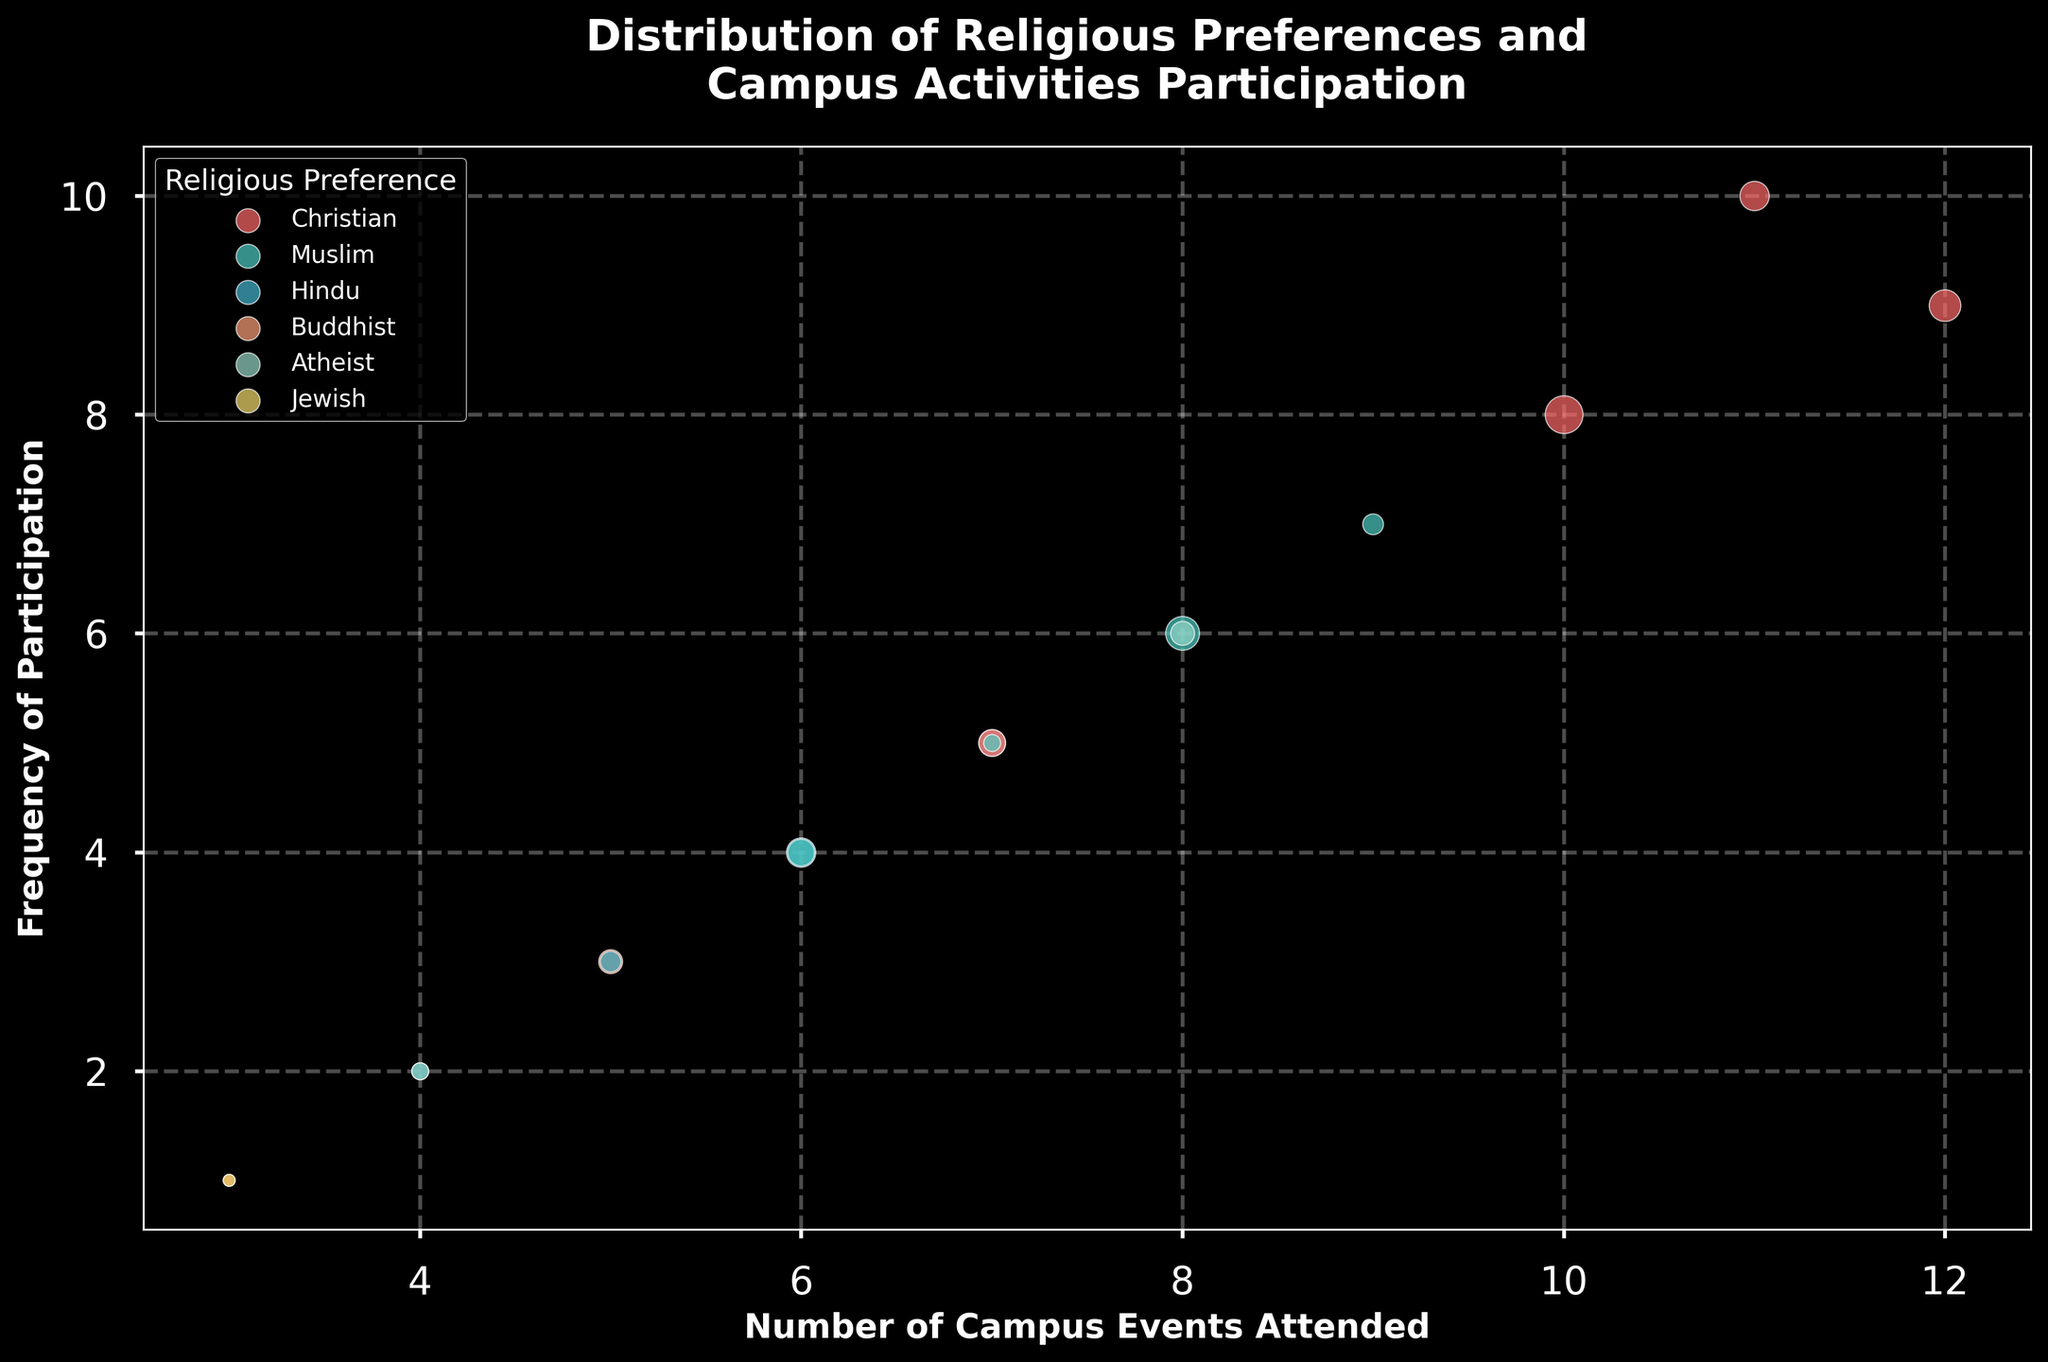What is the title of the chart? The title of the chart is located at the top of the figure, and it provides a summary of the visual content.
Answer: Distribution of Religious Preferences and Campus Activities Participation What is the color used for Christian students in the bubble chart? Each religious preference is represented by a specific color. Christian students are represented with a distinct color.
Answer: Red How many campus events are attended by Muslims who frequently participate 7 times? Locate the bubble representing Muslim students with a frequency of participation of 7. Then, check the corresponding number of campus events attended.
Answer: 9 Which religious preference has the highest frequency of participation and how many students does it represent? To determine this, look for the bubble at the highest point on the y-axis and check the religious preference and the size of the bubble to find the number of students.
Answer: Christian, 30 students What is the total number of events attended by Christian students? To find this, sum the number of campus events attended by all Christian students shown in the data.
Answer: 10 + 12 + 11 + 7 = 40 Which religious preference has the smallest bubble and how many students does that bubble represent? The smallest bubble is identified by the smallest visual size. Look closely to find the smallest bubble and its corresponding student count and religious preference.
Answer: Jewish, 5 students What is the relationship between the number of campus events attended and frequency of participation for Atheist students? Check the series of bubbles representing Atheist students and observe the trend in the x and y values to determine the relationship.
Answer: Positive correlation If you combine all students that attended at least 7 events, what is their combined attendance? This involves summing the campus events attended for bubbles where the x-axis value is 7 or greater.
Answer: Christian: 10+12+11+7, Muslim: 8+9+7, Atheist: 7+8; Total = 73 What can you say about the participation frequency of students who have attended 4 campus events across different religious preferences? Identify the bubbles corresponding to 4 campus events on the x-axis and compare their frequencies on the y-axis.
Answer: Hindus have the lowest participation frequency at 2, Atheists at 2 